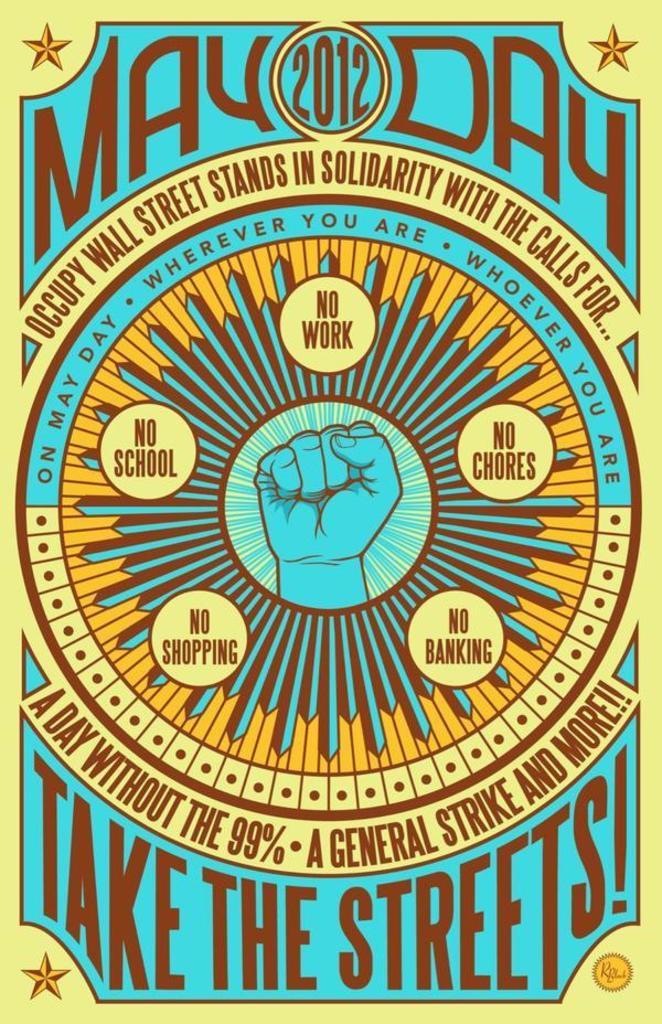What is the ad for?
Ensure brevity in your answer.  May day 2012. 